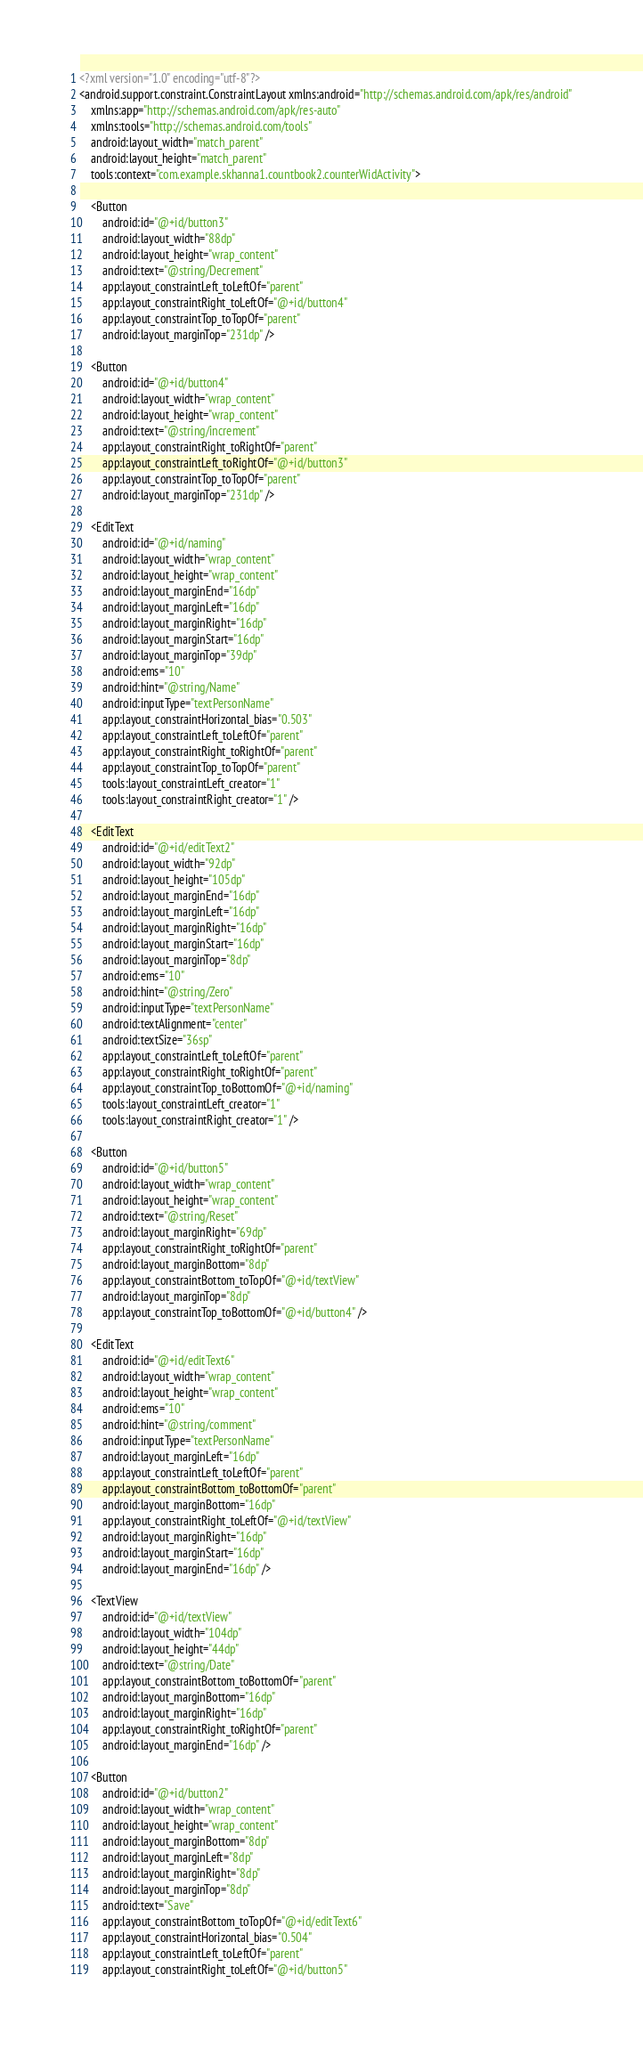<code> <loc_0><loc_0><loc_500><loc_500><_XML_><?xml version="1.0" encoding="utf-8"?>
<android.support.constraint.ConstraintLayout xmlns:android="http://schemas.android.com/apk/res/android"
    xmlns:app="http://schemas.android.com/apk/res-auto"
    xmlns:tools="http://schemas.android.com/tools"
    android:layout_width="match_parent"
    android:layout_height="match_parent"
    tools:context="com.example.skhanna1.countbook2.counterWidActivity">

    <Button
        android:id="@+id/button3"
        android:layout_width="88dp"
        android:layout_height="wrap_content"
        android:text="@string/Decrement"
        app:layout_constraintLeft_toLeftOf="parent"
        app:layout_constraintRight_toLeftOf="@+id/button4"
        app:layout_constraintTop_toTopOf="parent"
        android:layout_marginTop="231dp" />

    <Button
        android:id="@+id/button4"
        android:layout_width="wrap_content"
        android:layout_height="wrap_content"
        android:text="@string/increment"
        app:layout_constraintRight_toRightOf="parent"
        app:layout_constraintLeft_toRightOf="@+id/button3"
        app:layout_constraintTop_toTopOf="parent"
        android:layout_marginTop="231dp" />

    <EditText
        android:id="@+id/naming"
        android:layout_width="wrap_content"
        android:layout_height="wrap_content"
        android:layout_marginEnd="16dp"
        android:layout_marginLeft="16dp"
        android:layout_marginRight="16dp"
        android:layout_marginStart="16dp"
        android:layout_marginTop="39dp"
        android:ems="10"
        android:hint="@string/Name"
        android:inputType="textPersonName"
        app:layout_constraintHorizontal_bias="0.503"
        app:layout_constraintLeft_toLeftOf="parent"
        app:layout_constraintRight_toRightOf="parent"
        app:layout_constraintTop_toTopOf="parent"
        tools:layout_constraintLeft_creator="1"
        tools:layout_constraintRight_creator="1" />

    <EditText
        android:id="@+id/editText2"
        android:layout_width="92dp"
        android:layout_height="105dp"
        android:layout_marginEnd="16dp"
        android:layout_marginLeft="16dp"
        android:layout_marginRight="16dp"
        android:layout_marginStart="16dp"
        android:layout_marginTop="8dp"
        android:ems="10"
        android:hint="@string/Zero"
        android:inputType="textPersonName"
        android:textAlignment="center"
        android:textSize="36sp"
        app:layout_constraintLeft_toLeftOf="parent"
        app:layout_constraintRight_toRightOf="parent"
        app:layout_constraintTop_toBottomOf="@+id/naming"
        tools:layout_constraintLeft_creator="1"
        tools:layout_constraintRight_creator="1" />

    <Button
        android:id="@+id/button5"
        android:layout_width="wrap_content"
        android:layout_height="wrap_content"
        android:text="@string/Reset"
        android:layout_marginRight="69dp"
        app:layout_constraintRight_toRightOf="parent"
        android:layout_marginBottom="8dp"
        app:layout_constraintBottom_toTopOf="@+id/textView"
        android:layout_marginTop="8dp"
        app:layout_constraintTop_toBottomOf="@+id/button4" />

    <EditText
        android:id="@+id/editText6"
        android:layout_width="wrap_content"
        android:layout_height="wrap_content"
        android:ems="10"
        android:hint="@string/comment"
        android:inputType="textPersonName"
        android:layout_marginLeft="16dp"
        app:layout_constraintLeft_toLeftOf="parent"
        app:layout_constraintBottom_toBottomOf="parent"
        android:layout_marginBottom="16dp"
        app:layout_constraintRight_toLeftOf="@+id/textView"
        android:layout_marginRight="16dp"
        android:layout_marginStart="16dp"
        android:layout_marginEnd="16dp" />

    <TextView
        android:id="@+id/textView"
        android:layout_width="104dp"
        android:layout_height="44dp"
        android:text="@string/Date"
        app:layout_constraintBottom_toBottomOf="parent"
        android:layout_marginBottom="16dp"
        android:layout_marginRight="16dp"
        app:layout_constraintRight_toRightOf="parent"
        android:layout_marginEnd="16dp" />

    <Button
        android:id="@+id/button2"
        android:layout_width="wrap_content"
        android:layout_height="wrap_content"
        android:layout_marginBottom="8dp"
        android:layout_marginLeft="8dp"
        android:layout_marginRight="8dp"
        android:layout_marginTop="8dp"
        android:text="Save"
        app:layout_constraintBottom_toTopOf="@+id/editText6"
        app:layout_constraintHorizontal_bias="0.504"
        app:layout_constraintLeft_toLeftOf="parent"
        app:layout_constraintRight_toLeftOf="@+id/button5"</code> 